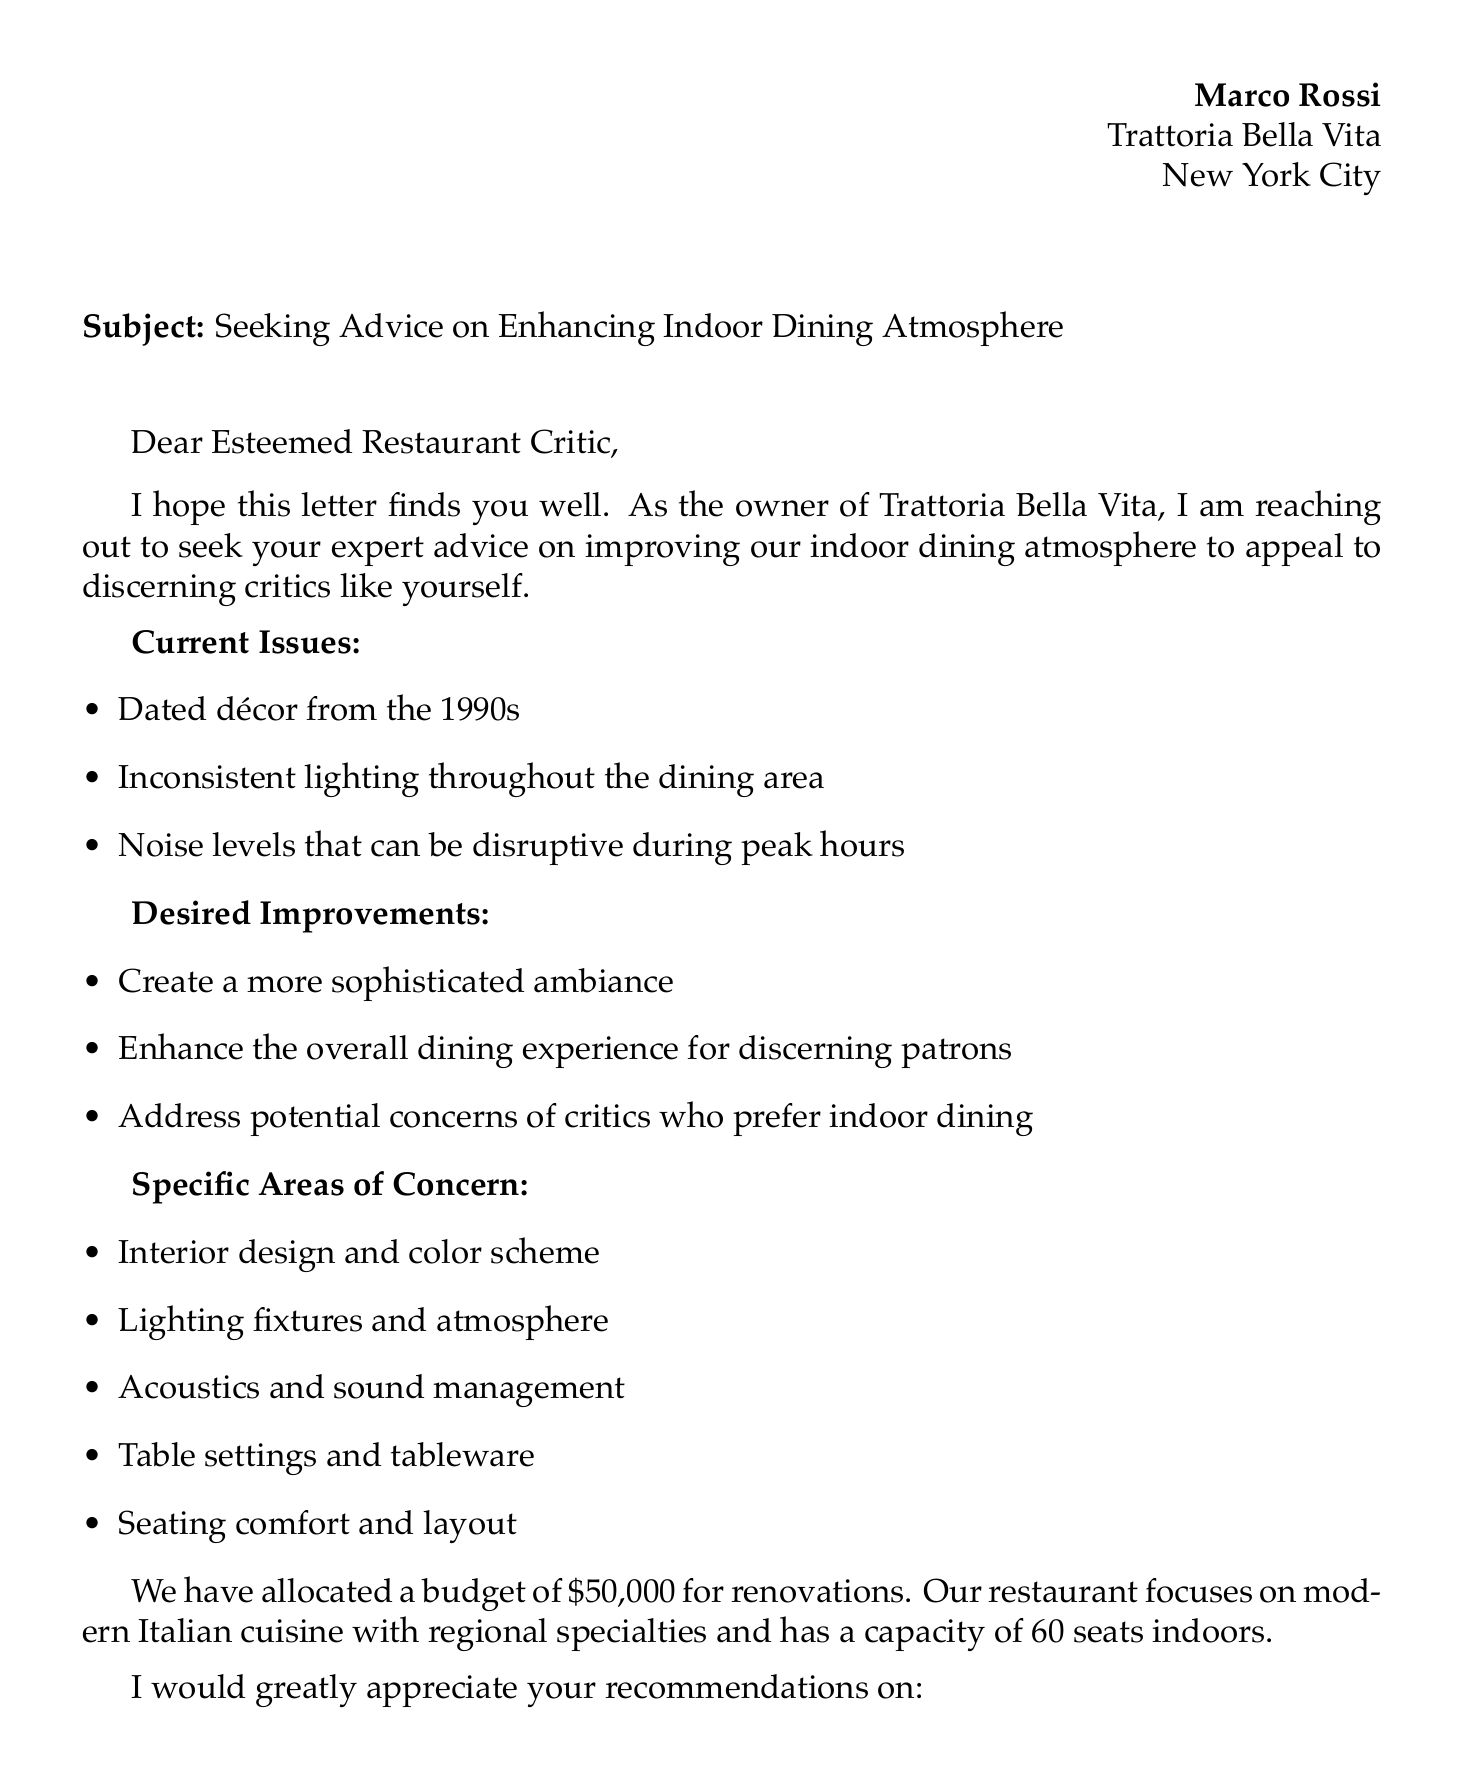What is the name of the restaurant owner? The document clearly identifies the sender as Marco Rossi, the owner of the restaurant.
Answer: Marco Rossi What is the restaurant's location? The letter specifies that Trattoria Bella Vita is situated in New York City.
Answer: New York City How much budget has been allocated for renovations? The budget for improvements is mentioned explicitly in the document.
Answer: $50,000 What type of cuisine does Trattoria Bella Vita focus on? The document outlines the restaurant's culinary focus, specifically mentioning the type of cuisine offered.
Answer: Modern Italian What are some of the current issues mentioned? The document lists specific problems that the restaurant is facing regarding its indoor dining atmosphere.
Answer: Dated décor from the 1990s, inconsistent lighting, noise levels What is the desired improvement mentioned in the document? The letter highlights the owner’s aim for the restaurant's ambiance and dining experience, reflecting the owner's aspirations.
Answer: Create a more sophisticated ambiance What specific area of concern relates to sound management? The document includes a section dedicated to specific areas that the owner wishes to address, which includes acoustics.
Answer: Acoustics and sound management How many seats does the restaurant have indoors? The document provides a specific detail about the restaurant's capacity regarding indoor seating.
Answer: 60 seats What is the purpose of Marco Rossi's letter? The letter clearly states the owner’s intention to seek advice on improving a particular aspect of his restaurant.
Answer: Enhancing indoor dining atmosphere 